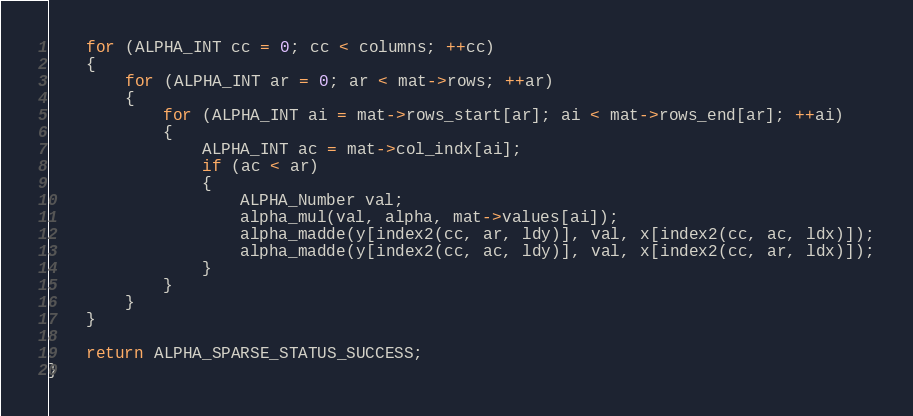Convert code to text. <code><loc_0><loc_0><loc_500><loc_500><_C_>
    for (ALPHA_INT cc = 0; cc < columns; ++cc)
    {
        for (ALPHA_INT ar = 0; ar < mat->rows; ++ar)
        {
            for (ALPHA_INT ai = mat->rows_start[ar]; ai < mat->rows_end[ar]; ++ai)
            {
                ALPHA_INT ac = mat->col_indx[ai];
                if (ac < ar)
                {
                    ALPHA_Number val;
                    alpha_mul(val, alpha, mat->values[ai]);
                    alpha_madde(y[index2(cc, ar, ldy)], val, x[index2(cc, ac, ldx)]);
                    alpha_madde(y[index2(cc, ac, ldy)], val, x[index2(cc, ar, ldx)]);
                }
            }
        }
    }

    return ALPHA_SPARSE_STATUS_SUCCESS;
}
</code> 